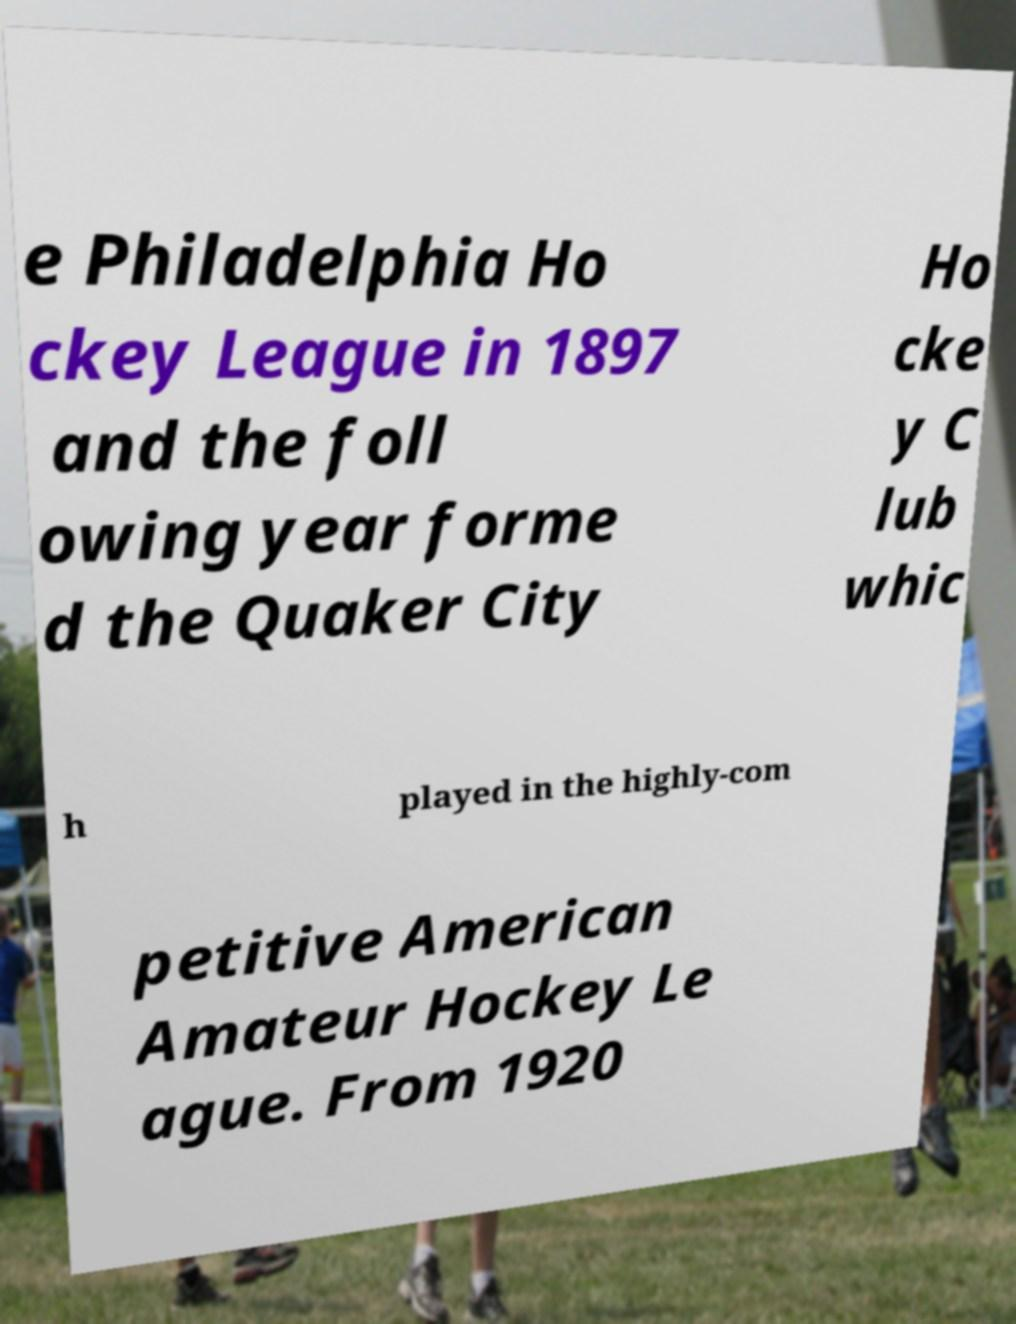What messages or text are displayed in this image? I need them in a readable, typed format. e Philadelphia Ho ckey League in 1897 and the foll owing year forme d the Quaker City Ho cke y C lub whic h played in the highly-com petitive American Amateur Hockey Le ague. From 1920 